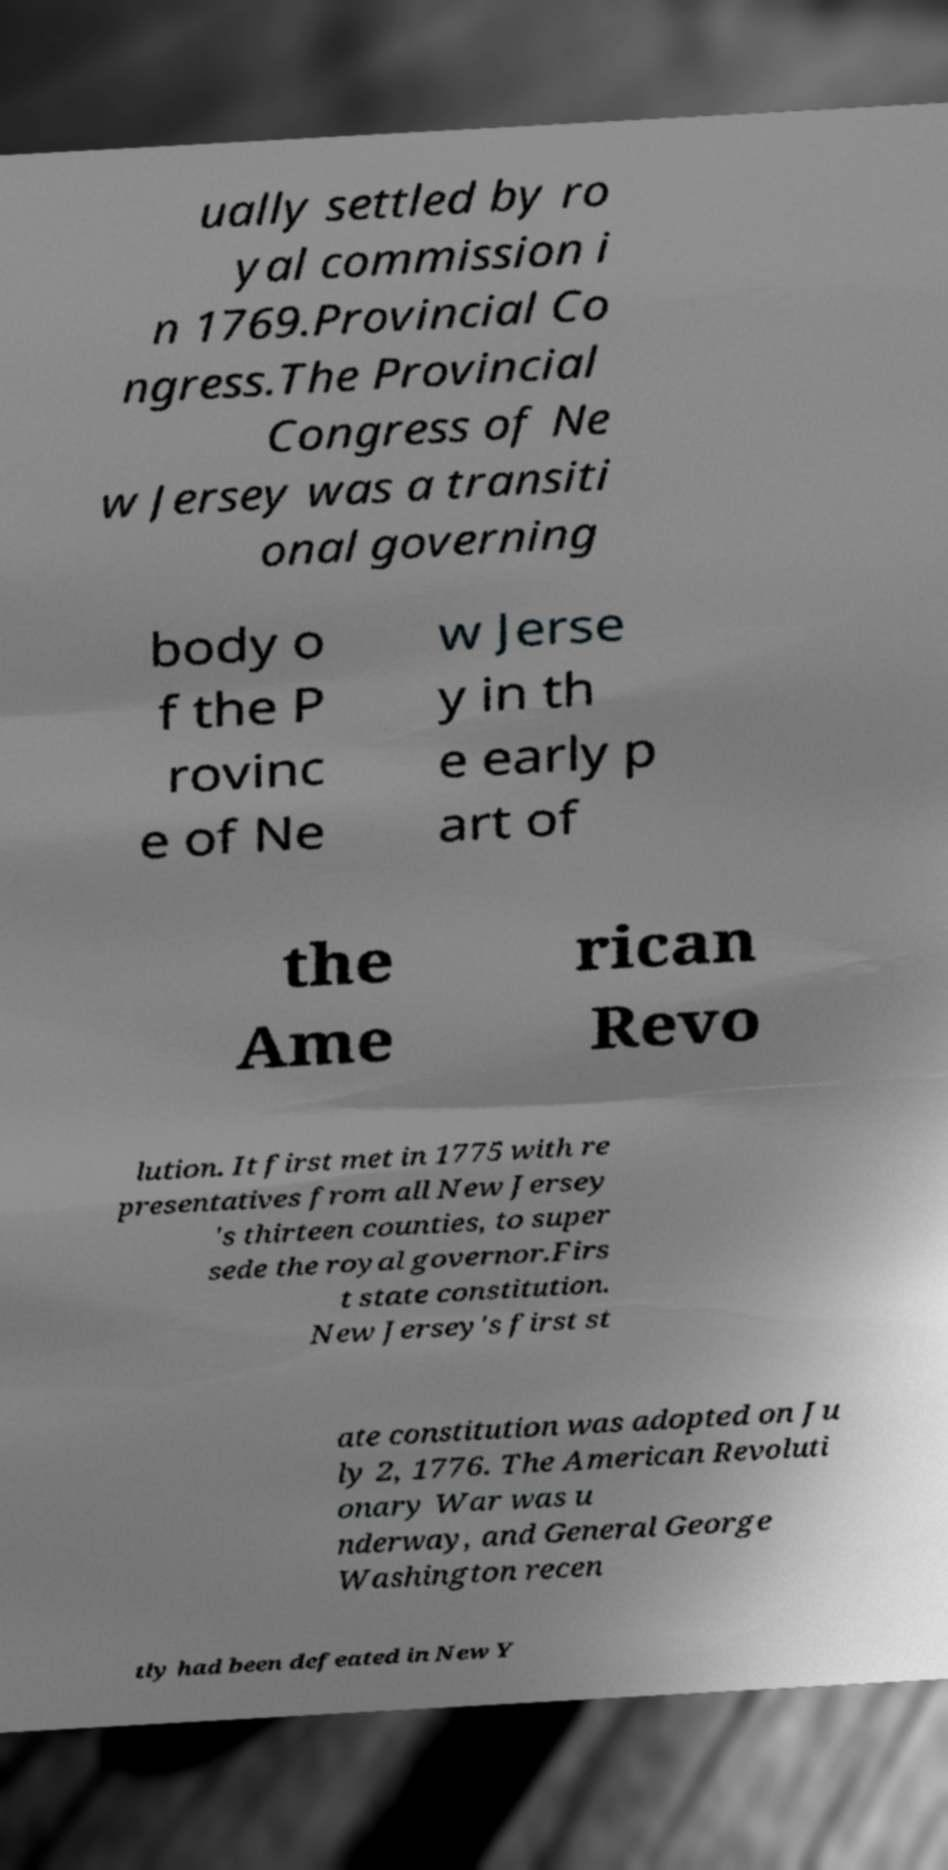There's text embedded in this image that I need extracted. Can you transcribe it verbatim? ually settled by ro yal commission i n 1769.Provincial Co ngress.The Provincial Congress of Ne w Jersey was a transiti onal governing body o f the P rovinc e of Ne w Jerse y in th e early p art of the Ame rican Revo lution. It first met in 1775 with re presentatives from all New Jersey 's thirteen counties, to super sede the royal governor.Firs t state constitution. New Jersey's first st ate constitution was adopted on Ju ly 2, 1776. The American Revoluti onary War was u nderway, and General George Washington recen tly had been defeated in New Y 